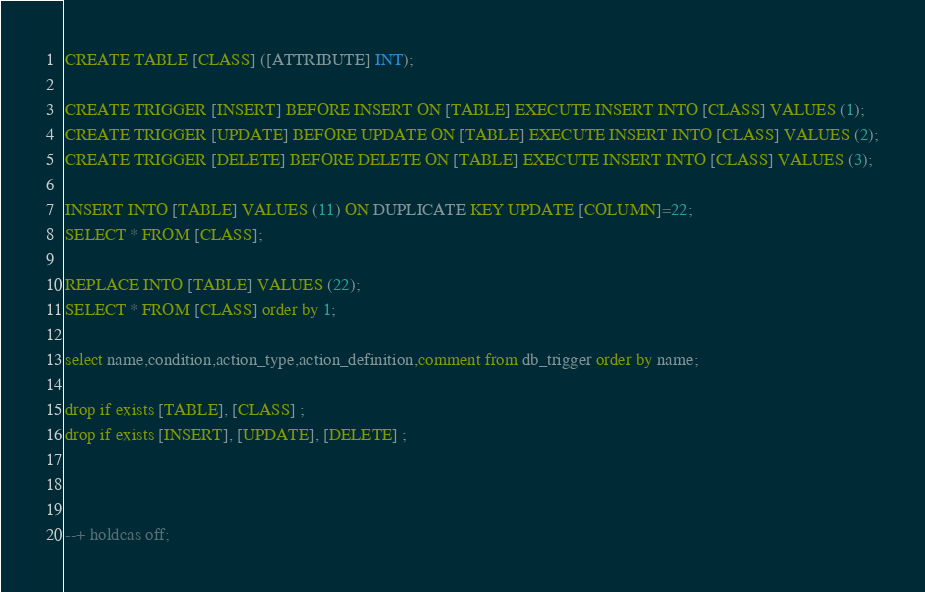Convert code to text. <code><loc_0><loc_0><loc_500><loc_500><_SQL_>CREATE TABLE [CLASS] ([ATTRIBUTE] INT);

CREATE TRIGGER [INSERT] BEFORE INSERT ON [TABLE] EXECUTE INSERT INTO [CLASS] VALUES (1);
CREATE TRIGGER [UPDATE] BEFORE UPDATE ON [TABLE] EXECUTE INSERT INTO [CLASS] VALUES (2);
CREATE TRIGGER [DELETE] BEFORE DELETE ON [TABLE] EXECUTE INSERT INTO [CLASS] VALUES (3);

INSERT INTO [TABLE] VALUES (11) ON DUPLICATE KEY UPDATE [COLUMN]=22;
SELECT * FROM [CLASS];

REPLACE INTO [TABLE] VALUES (22);
SELECT * FROM [CLASS] order by 1;

select name,condition,action_type,action_definition,comment from db_trigger order by name;

drop if exists [TABLE], [CLASS] ;
drop if exists [INSERT], [UPDATE], [DELETE] ;



--+ holdcas off;
</code> 